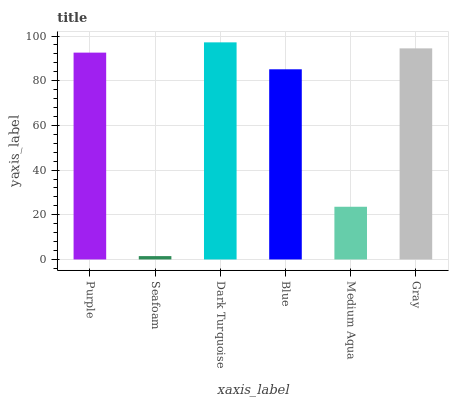Is Dark Turquoise the minimum?
Answer yes or no. No. Is Seafoam the maximum?
Answer yes or no. No. Is Dark Turquoise greater than Seafoam?
Answer yes or no. Yes. Is Seafoam less than Dark Turquoise?
Answer yes or no. Yes. Is Seafoam greater than Dark Turquoise?
Answer yes or no. No. Is Dark Turquoise less than Seafoam?
Answer yes or no. No. Is Purple the high median?
Answer yes or no. Yes. Is Blue the low median?
Answer yes or no. Yes. Is Seafoam the high median?
Answer yes or no. No. Is Purple the low median?
Answer yes or no. No. 